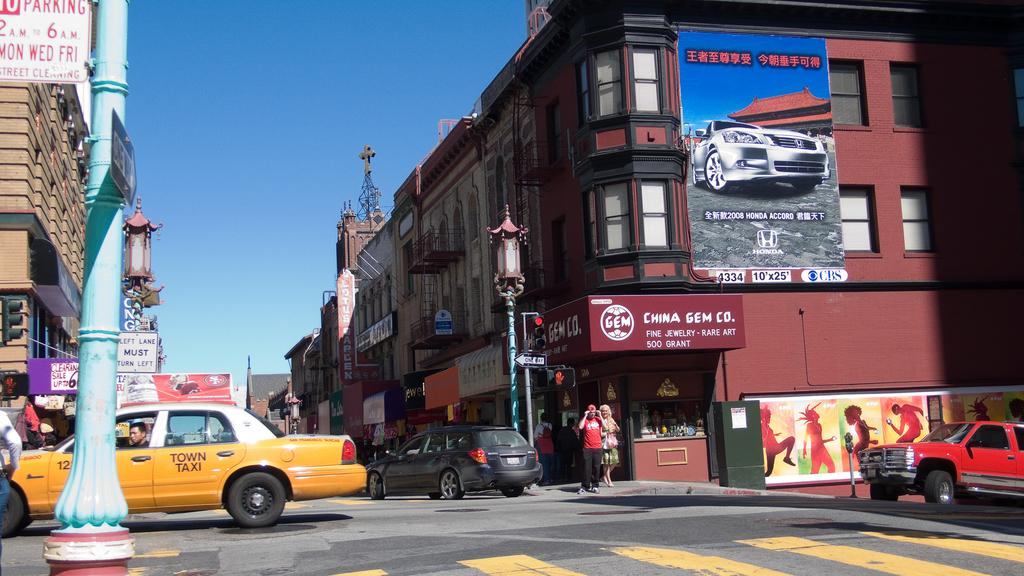Provide a one-sentence caption for the provided image. People walk across a crosswalk in front of a yellow taxi in the city. 